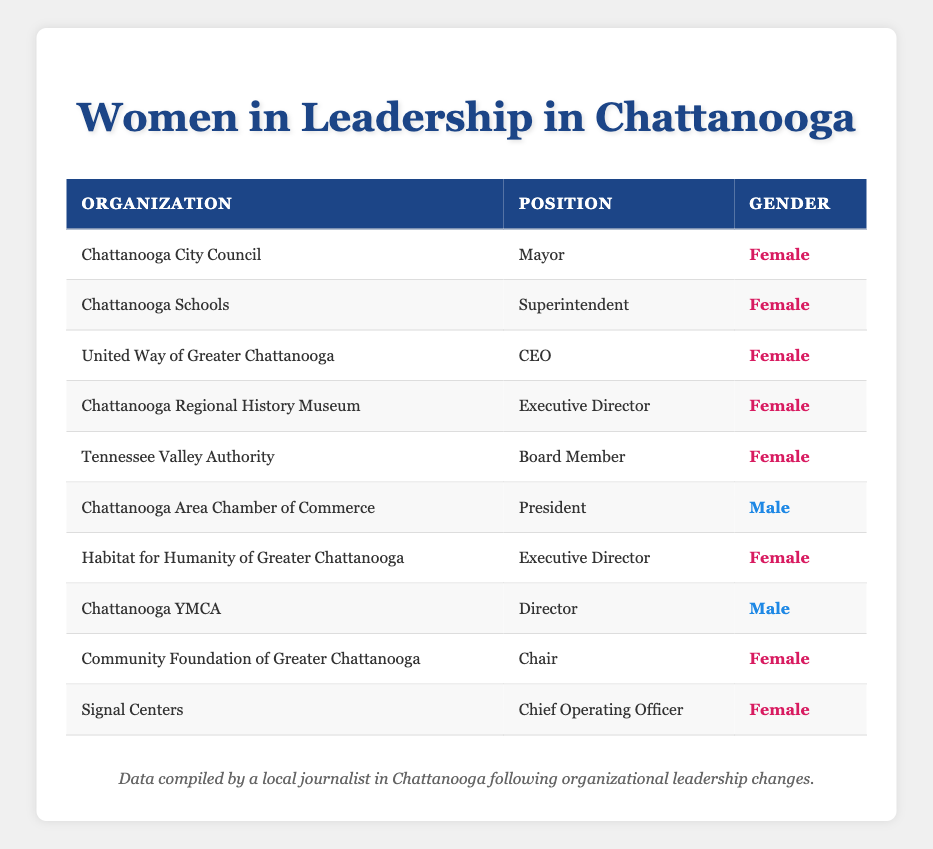What percentage of leadership positions are held by women? There are a total of 10 leadership positions listed in the table. Out of these, 7 positions are held by women. To find the percentage, we calculate (7/10) * 100 = 70%.
Answer: 70% How many organizations have female leadership? The table lists 10 organizations. By counting the rows where the gender is marked as "Female", we find that 7 organizations have female leadership.
Answer: 7 Which position is held by the only male leader? Looking through the table, the "Chattanooga Area Chamber of Commerce" has a male president, and the "Chattanooga YMCA" has a male director. Since the question asks for the only position held by a male leader, we need to identify one, and either position will suffice. The answer can be the one from the first found.
Answer: President Is the position of Superintendent held by a woman? Checking the entry for "Chattanooga Schools", we see that the gender for the position of Superintendent is "Female". Therefore, the answer is yes.
Answer: Yes What is the average number of female leaders per organization for those organizations led by women? There are 7 female leaders listed. To find the average, we divide the number of female leaders by the number of organizations with female leadership. Since 7 positions were held by 7 different organizations, the average number is (7/7) = 1.
Answer: 1 How many positions listed in the table correspond to male leadership? From the table, we see that there are 3 rows that show male leadership: "Chattanooga Area Chamber of Commerce" with its President, and "Chattanooga YMCA" with its Director. Thus, the total count is 3.
Answer: 3 Is there any female CEO position listed in the table? One of the rows indicates that the "United Way of Greater Chattanooga" has a female CEO. This confirms that there is indeed a female CEO position listed.
Answer: Yes Which organization has the lowest leadership position held by a female? Based on the table, the positions range in hierarchy; however, the "Chief Operating Officer" at "Signal Centers" can be considered a less prominent position compared to "CEO" or "Mayor". Hence, in this context, this could be interpreted as it being the lowest.
Answer: Chief Operating Officer 